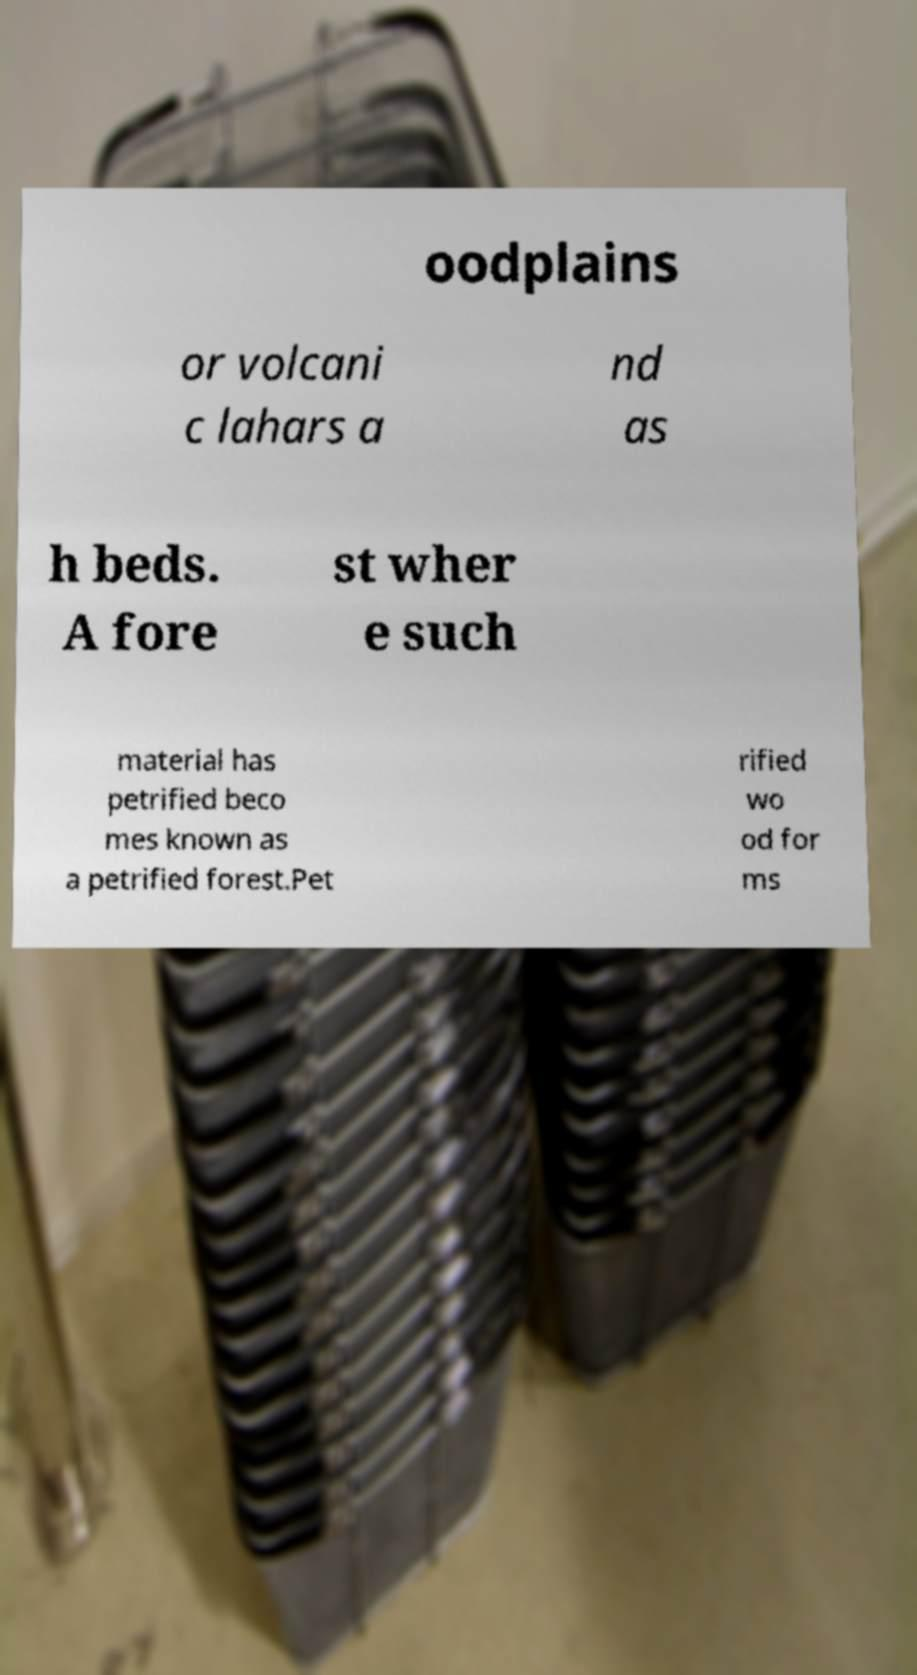Please identify and transcribe the text found in this image. oodplains or volcani c lahars a nd as h beds. A fore st wher e such material has petrified beco mes known as a petrified forest.Pet rified wo od for ms 